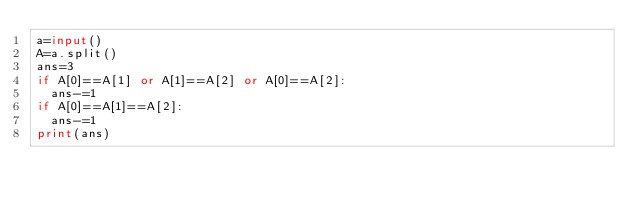<code> <loc_0><loc_0><loc_500><loc_500><_Python_>a=input()
A=a.split()
ans=3
if A[0]==A[1] or A[1]==A[2] or A[0]==A[2]:
  ans-=1
if A[0]==A[1]==A[2]:
  ans-=1
print(ans)</code> 